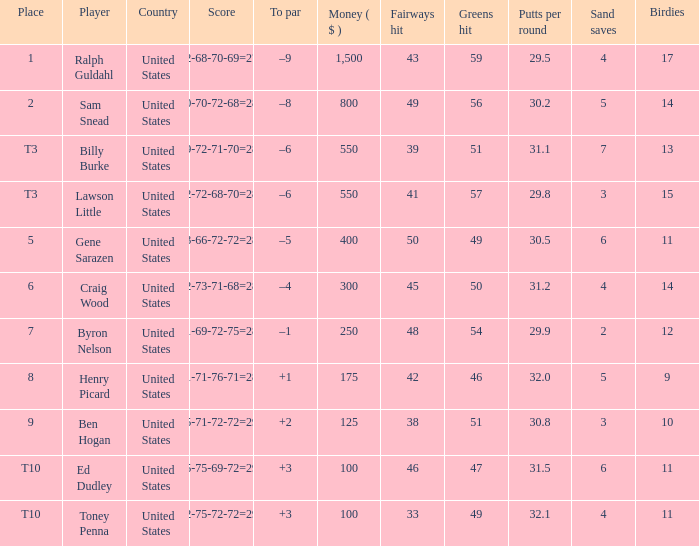Which country has a prize smaller than $250 and the player Henry Picard? United States. 